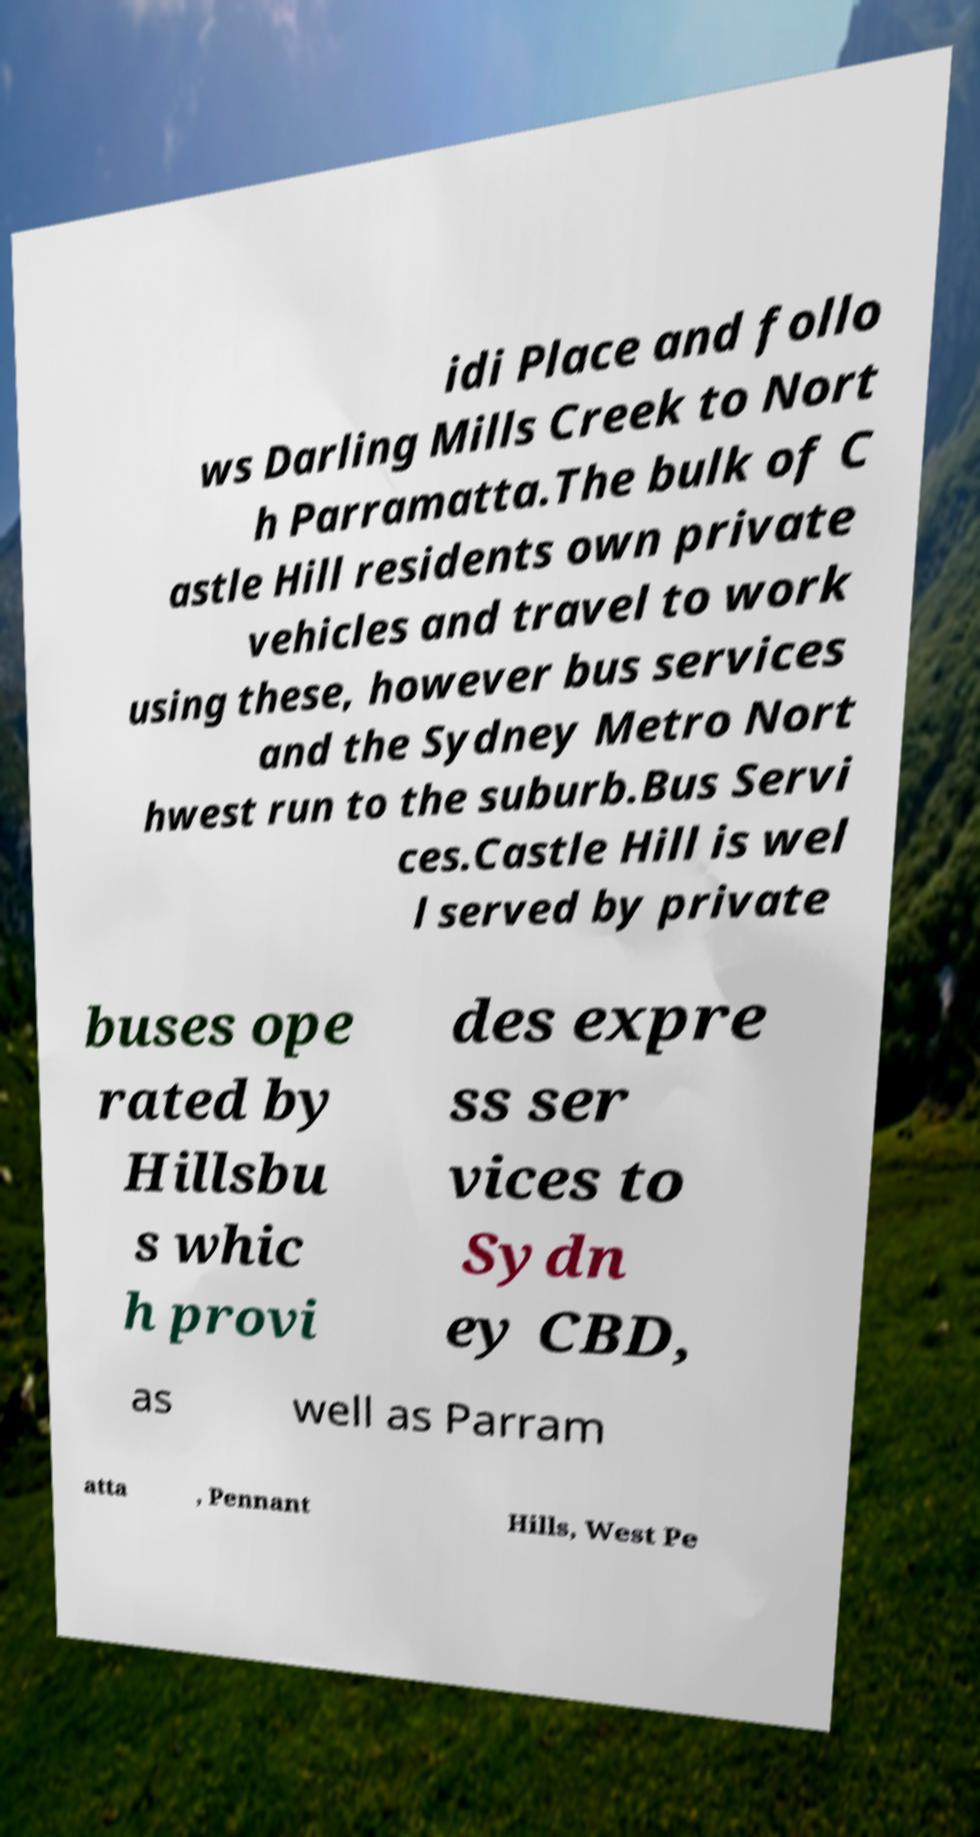Could you assist in decoding the text presented in this image and type it out clearly? idi Place and follo ws Darling Mills Creek to Nort h Parramatta.The bulk of C astle Hill residents own private vehicles and travel to work using these, however bus services and the Sydney Metro Nort hwest run to the suburb.Bus Servi ces.Castle Hill is wel l served by private buses ope rated by Hillsbu s whic h provi des expre ss ser vices to Sydn ey CBD, as well as Parram atta , Pennant Hills, West Pe 